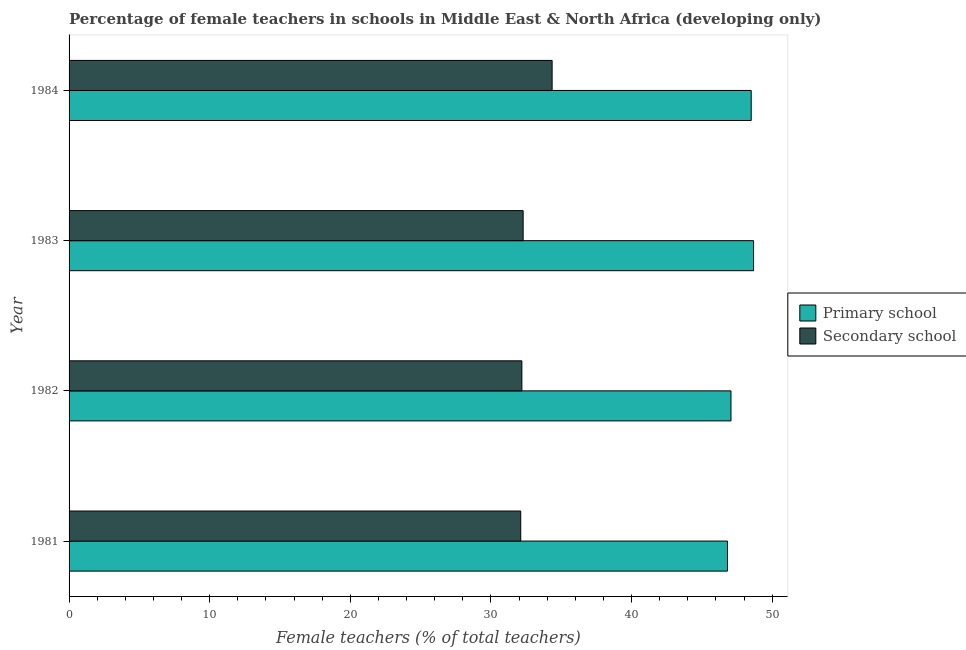How many different coloured bars are there?
Your answer should be compact. 2. Are the number of bars per tick equal to the number of legend labels?
Provide a short and direct response. Yes. What is the label of the 2nd group of bars from the top?
Make the answer very short. 1983. In how many cases, is the number of bars for a given year not equal to the number of legend labels?
Provide a succinct answer. 0. What is the percentage of female teachers in secondary schools in 1983?
Make the answer very short. 32.29. Across all years, what is the maximum percentage of female teachers in primary schools?
Offer a terse response. 48.67. Across all years, what is the minimum percentage of female teachers in secondary schools?
Your answer should be compact. 32.12. In which year was the percentage of female teachers in primary schools minimum?
Give a very brief answer. 1981. What is the total percentage of female teachers in secondary schools in the graph?
Make the answer very short. 130.95. What is the difference between the percentage of female teachers in secondary schools in 1981 and that in 1984?
Ensure brevity in your answer.  -2.23. What is the difference between the percentage of female teachers in primary schools in 1982 and the percentage of female teachers in secondary schools in 1981?
Provide a succinct answer. 14.95. What is the average percentage of female teachers in secondary schools per year?
Offer a terse response. 32.74. In the year 1982, what is the difference between the percentage of female teachers in secondary schools and percentage of female teachers in primary schools?
Provide a short and direct response. -14.87. In how many years, is the percentage of female teachers in secondary schools greater than 24 %?
Offer a very short reply. 4. Is the percentage of female teachers in primary schools in 1981 less than that in 1984?
Keep it short and to the point. Yes. What is the difference between the highest and the second highest percentage of female teachers in secondary schools?
Give a very brief answer. 2.06. What is the difference between the highest and the lowest percentage of female teachers in secondary schools?
Your answer should be compact. 2.23. In how many years, is the percentage of female teachers in primary schools greater than the average percentage of female teachers in primary schools taken over all years?
Your answer should be compact. 2. What does the 2nd bar from the top in 1983 represents?
Make the answer very short. Primary school. What does the 2nd bar from the bottom in 1982 represents?
Offer a very short reply. Secondary school. How many years are there in the graph?
Offer a terse response. 4. Does the graph contain grids?
Offer a terse response. No. How many legend labels are there?
Provide a succinct answer. 2. What is the title of the graph?
Your answer should be compact. Percentage of female teachers in schools in Middle East & North Africa (developing only). Does "Under-5(male)" appear as one of the legend labels in the graph?
Keep it short and to the point. No. What is the label or title of the X-axis?
Keep it short and to the point. Female teachers (% of total teachers). What is the label or title of the Y-axis?
Keep it short and to the point. Year. What is the Female teachers (% of total teachers) in Primary school in 1981?
Your answer should be very brief. 46.82. What is the Female teachers (% of total teachers) in Secondary school in 1981?
Provide a short and direct response. 32.12. What is the Female teachers (% of total teachers) of Primary school in 1982?
Your answer should be compact. 47.06. What is the Female teachers (% of total teachers) of Secondary school in 1982?
Provide a short and direct response. 32.2. What is the Female teachers (% of total teachers) of Primary school in 1983?
Provide a succinct answer. 48.67. What is the Female teachers (% of total teachers) of Secondary school in 1983?
Offer a terse response. 32.29. What is the Female teachers (% of total teachers) of Primary school in 1984?
Provide a succinct answer. 48.5. What is the Female teachers (% of total teachers) in Secondary school in 1984?
Your answer should be compact. 34.35. Across all years, what is the maximum Female teachers (% of total teachers) of Primary school?
Your answer should be very brief. 48.67. Across all years, what is the maximum Female teachers (% of total teachers) in Secondary school?
Ensure brevity in your answer.  34.35. Across all years, what is the minimum Female teachers (% of total teachers) of Primary school?
Keep it short and to the point. 46.82. Across all years, what is the minimum Female teachers (% of total teachers) in Secondary school?
Provide a short and direct response. 32.12. What is the total Female teachers (% of total teachers) of Primary school in the graph?
Your answer should be very brief. 191.06. What is the total Female teachers (% of total teachers) in Secondary school in the graph?
Make the answer very short. 130.95. What is the difference between the Female teachers (% of total teachers) in Primary school in 1981 and that in 1982?
Keep it short and to the point. -0.25. What is the difference between the Female teachers (% of total teachers) in Secondary school in 1981 and that in 1982?
Provide a short and direct response. -0.08. What is the difference between the Female teachers (% of total teachers) in Primary school in 1981 and that in 1983?
Make the answer very short. -1.86. What is the difference between the Female teachers (% of total teachers) of Secondary school in 1981 and that in 1983?
Your response must be concise. -0.17. What is the difference between the Female teachers (% of total teachers) of Primary school in 1981 and that in 1984?
Make the answer very short. -1.69. What is the difference between the Female teachers (% of total teachers) in Secondary school in 1981 and that in 1984?
Your answer should be very brief. -2.23. What is the difference between the Female teachers (% of total teachers) in Primary school in 1982 and that in 1983?
Offer a very short reply. -1.61. What is the difference between the Female teachers (% of total teachers) in Secondary school in 1982 and that in 1983?
Your answer should be very brief. -0.09. What is the difference between the Female teachers (% of total teachers) of Primary school in 1982 and that in 1984?
Your response must be concise. -1.44. What is the difference between the Female teachers (% of total teachers) of Secondary school in 1982 and that in 1984?
Give a very brief answer. -2.15. What is the difference between the Female teachers (% of total teachers) in Primary school in 1983 and that in 1984?
Your answer should be compact. 0.17. What is the difference between the Female teachers (% of total teachers) of Secondary school in 1983 and that in 1984?
Your answer should be very brief. -2.06. What is the difference between the Female teachers (% of total teachers) in Primary school in 1981 and the Female teachers (% of total teachers) in Secondary school in 1982?
Give a very brief answer. 14.62. What is the difference between the Female teachers (% of total teachers) of Primary school in 1981 and the Female teachers (% of total teachers) of Secondary school in 1983?
Your response must be concise. 14.53. What is the difference between the Female teachers (% of total teachers) of Primary school in 1981 and the Female teachers (% of total teachers) of Secondary school in 1984?
Provide a succinct answer. 12.47. What is the difference between the Female teachers (% of total teachers) of Primary school in 1982 and the Female teachers (% of total teachers) of Secondary school in 1983?
Provide a succinct answer. 14.78. What is the difference between the Female teachers (% of total teachers) of Primary school in 1982 and the Female teachers (% of total teachers) of Secondary school in 1984?
Make the answer very short. 12.72. What is the difference between the Female teachers (% of total teachers) in Primary school in 1983 and the Female teachers (% of total teachers) in Secondary school in 1984?
Your answer should be very brief. 14.32. What is the average Female teachers (% of total teachers) in Primary school per year?
Offer a very short reply. 47.76. What is the average Female teachers (% of total teachers) in Secondary school per year?
Provide a short and direct response. 32.74. In the year 1981, what is the difference between the Female teachers (% of total teachers) in Primary school and Female teachers (% of total teachers) in Secondary school?
Provide a short and direct response. 14.7. In the year 1982, what is the difference between the Female teachers (% of total teachers) of Primary school and Female teachers (% of total teachers) of Secondary school?
Your answer should be compact. 14.87. In the year 1983, what is the difference between the Female teachers (% of total teachers) in Primary school and Female teachers (% of total teachers) in Secondary school?
Your answer should be very brief. 16.39. In the year 1984, what is the difference between the Female teachers (% of total teachers) of Primary school and Female teachers (% of total teachers) of Secondary school?
Ensure brevity in your answer.  14.16. What is the ratio of the Female teachers (% of total teachers) in Primary school in 1981 to that in 1983?
Ensure brevity in your answer.  0.96. What is the ratio of the Female teachers (% of total teachers) in Primary school in 1981 to that in 1984?
Your answer should be compact. 0.97. What is the ratio of the Female teachers (% of total teachers) in Secondary school in 1981 to that in 1984?
Provide a succinct answer. 0.94. What is the ratio of the Female teachers (% of total teachers) of Primary school in 1982 to that in 1984?
Offer a very short reply. 0.97. What is the ratio of the Female teachers (% of total teachers) of Secondary school in 1982 to that in 1984?
Make the answer very short. 0.94. What is the ratio of the Female teachers (% of total teachers) in Secondary school in 1983 to that in 1984?
Offer a very short reply. 0.94. What is the difference between the highest and the second highest Female teachers (% of total teachers) in Primary school?
Your answer should be very brief. 0.17. What is the difference between the highest and the second highest Female teachers (% of total teachers) of Secondary school?
Your answer should be compact. 2.06. What is the difference between the highest and the lowest Female teachers (% of total teachers) in Primary school?
Provide a short and direct response. 1.86. What is the difference between the highest and the lowest Female teachers (% of total teachers) of Secondary school?
Give a very brief answer. 2.23. 